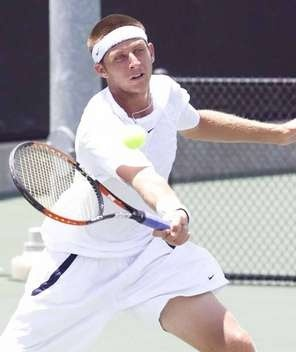Describe the objects in this image and their specific colors. I can see people in black, lavender, darkgray, and gray tones, tennis racket in black, lightgray, darkgray, and gray tones, and sports ball in khaki, lightyellow, black, and white tones in this image. 